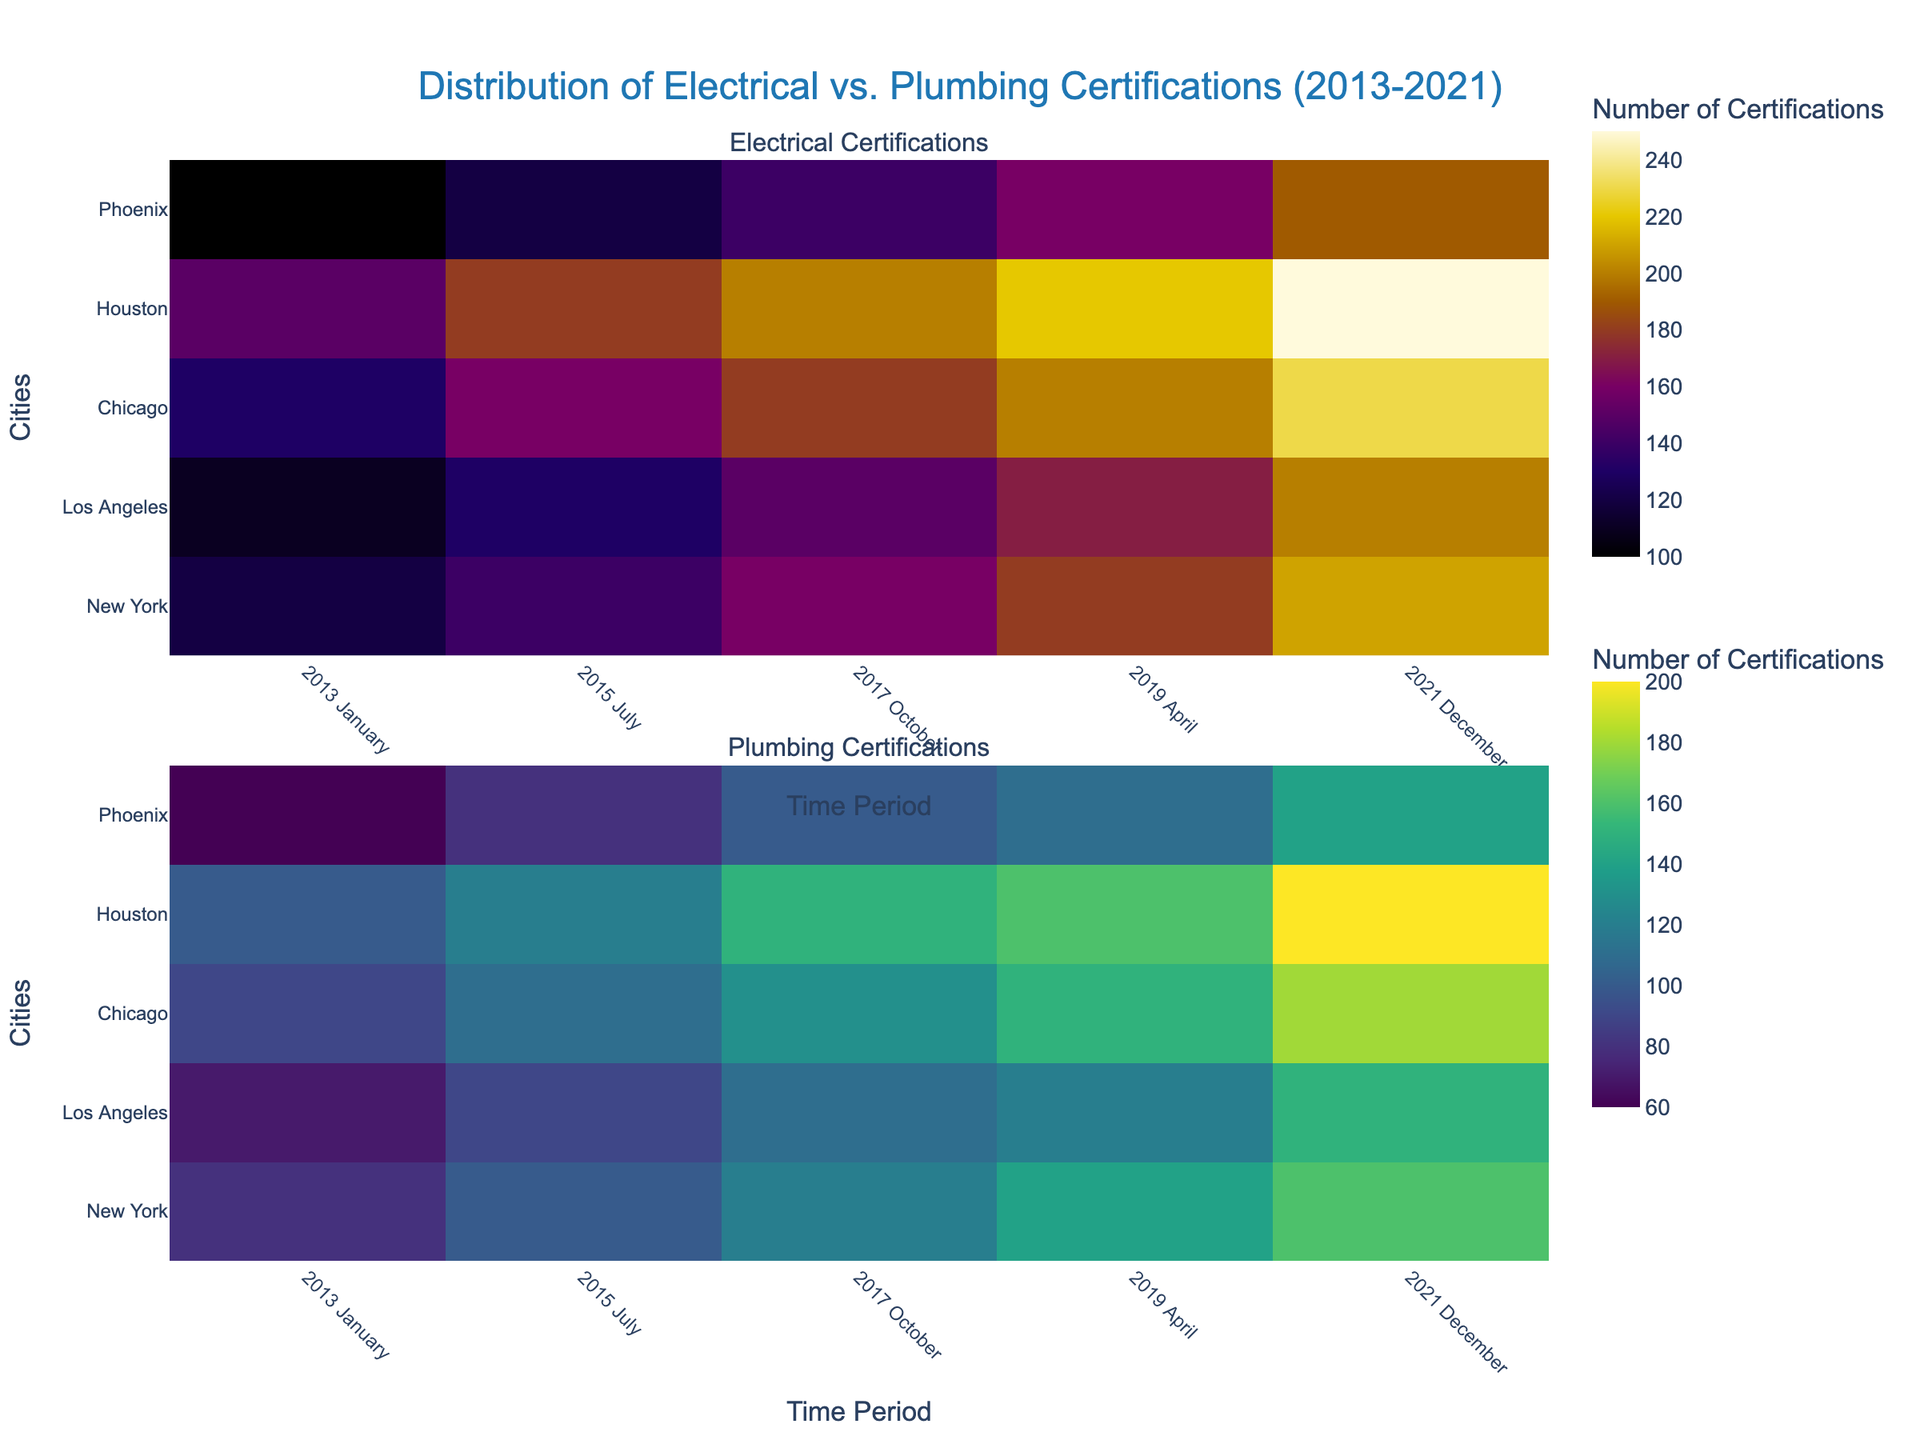What is the title of the figure? The title is displayed prominently at the top of the figure and usually provides a summary of what the plot is about.
Answer: Distribution of Electrical vs. Plumbing Certifications (2013-2021) What are the two subplot titles in the figure? The subplot titles are located at the top of each subplot and describe the specific data each subplot is showing.
Answer: Electrical Certifications, Plumbing Certifications Which city had the highest number of electrical certifications in 2021 December? Look at the heatmap for electrical certifications, find the column corresponding to "2021 December," and identify the city with the darkest color, indicating the highest value. New York is the darkest.
Answer: New York How do the electrical certifications in Houston for 2013 January compare to 2017 October? Locate Houston on the y-axis, then compare the colors in the columns for "2013 January" and "2017 October." The color intensity for "2017 October" is greater than for "2013 January," reflecting an increase.
Answer: Increased Which certification type saw a higher increase in New York from 2013 January to 2021 December? Compare the colors for New York in "2013 January" and "2021 December" for both electrical and plumbing certifications. The increase in color intensity is greater for electrical certifications.
Answer: Electrical Certifications In which year and month did Phoenix see its highest number of plumbing certifications? Check where Phoenix appears darkest in the plumbing certifications heatmap. The darkest color for Phoenix is in "2021 December."
Answer: 2021 December Compare the difference in the number of electrical certifications and plumbing certifications for Los Angeles in 2019 April. Find both values in the respective heatmaps for Los Angeles in "2019 April" and calculate the difference: electrical: 200, plumbing: 150, difference: 50.
Answer: 50 Which city shows the least variation in electrical certifications over all the years? Look for the row in the electrical certifications heatmap with the least color variation. Phoenix's row shows the least variation.
Answer: Phoenix What trend can be observed in the number of plumbing certifications in Chicago from 2013 to 2021? Observe the color intensity for Chicago in the plumbing certifications heatmap from left to right. The color intensifies consistently, indicating an increasing trend.
Answer: Increasing Trend Between electrical and plumbing certifications, which one had consistently higher numbers across all cities and years? Compare the general intensity and range of colors in both subplots and note that electrical certifications heatmap has a higher color intensity throughout.
Answer: Electrical Certifications 